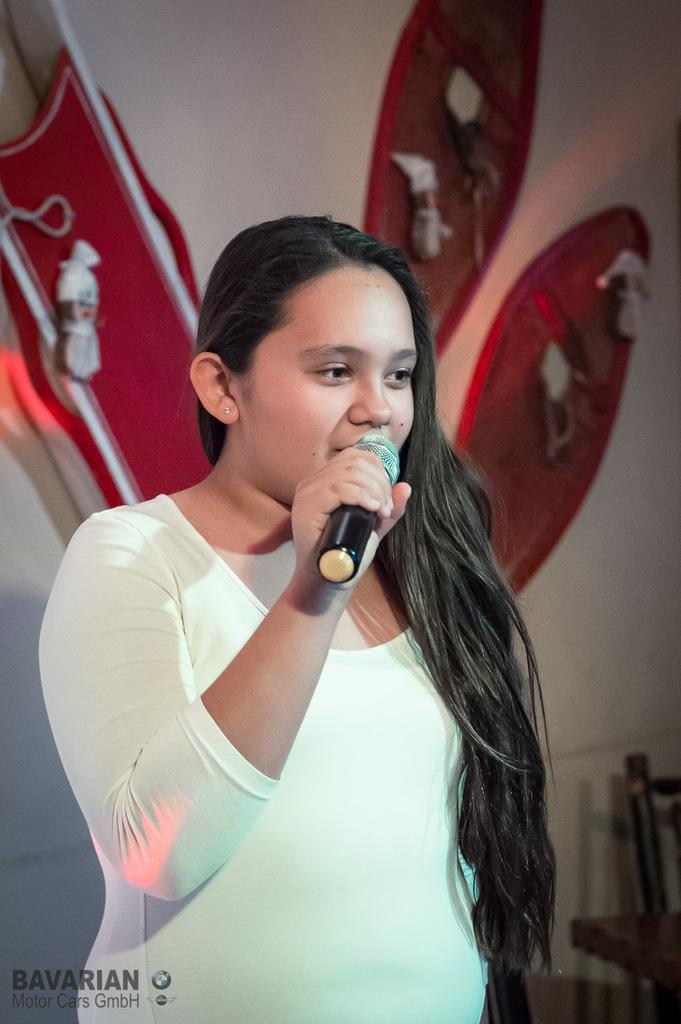What is the main subject of the picture? The main subject of the picture is a woman standing in the center. What is the woman doing in the picture? The woman is singing in the picture. Can you describe the background of the image? There is a design in the background of the image. How many sheep can be seen in the background of the image? There are no sheep present in the image; the background features a design. What type of ship is visible in the image? There is no ship present in the image; it features a woman singing and a background design. 